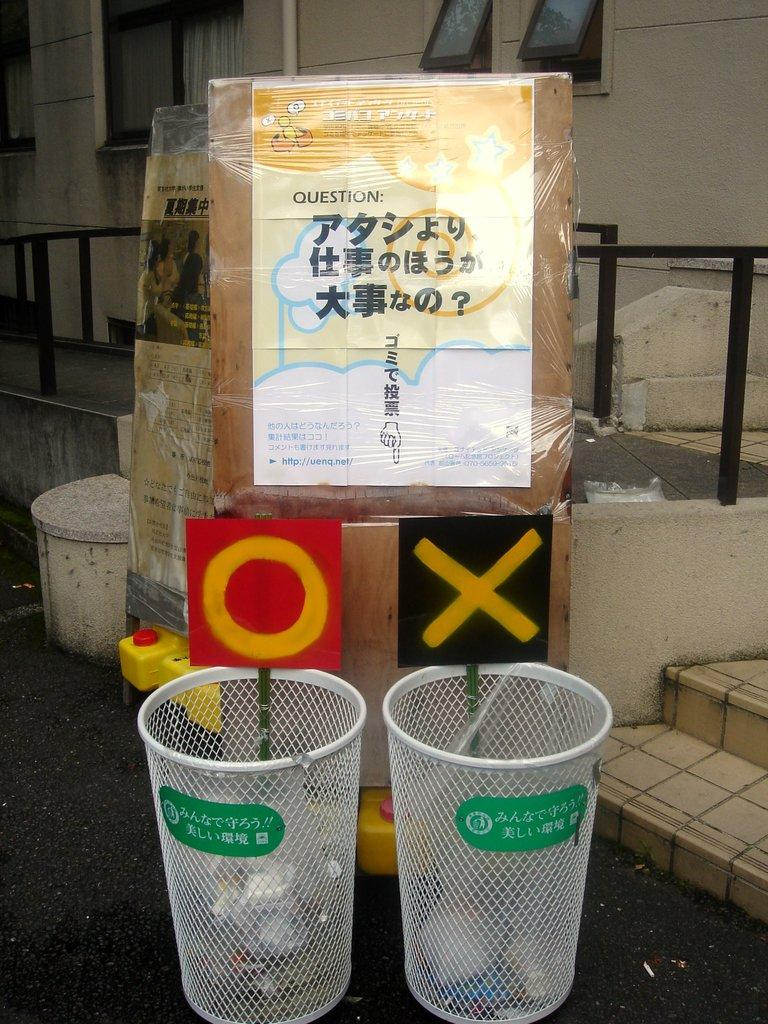<image>
Share a concise interpretation of the image provided. two basket cans that have an o above one and an x above the other. 